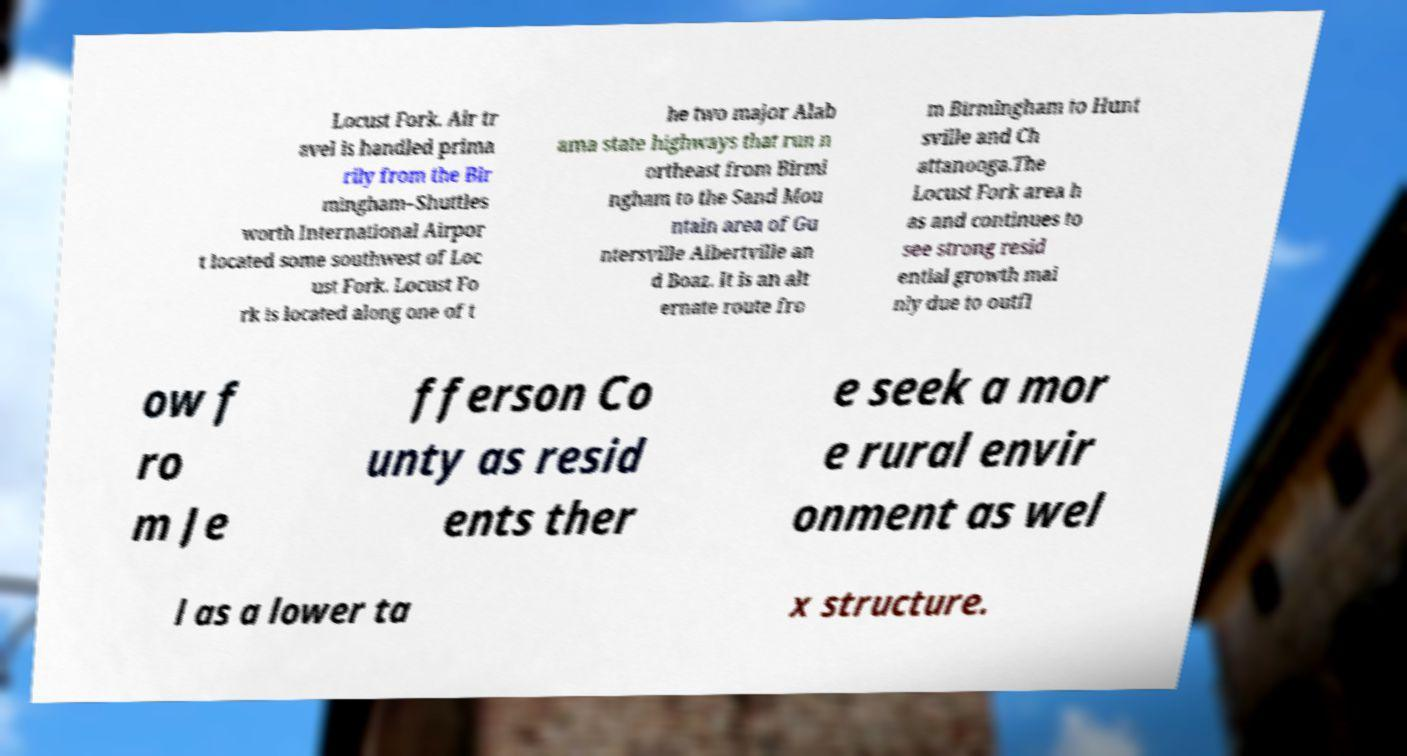Please read and relay the text visible in this image. What does it say? Locust Fork. Air tr avel is handled prima rily from the Bir mingham–Shuttles worth International Airpor t located some southwest of Loc ust Fork. Locust Fo rk is located along one of t he two major Alab ama state highways that run n ortheast from Birmi ngham to the Sand Mou ntain area of Gu ntersville Albertville an d Boaz. It is an alt ernate route fro m Birmingham to Hunt sville and Ch attanooga.The Locust Fork area h as and continues to see strong resid ential growth mai nly due to outfl ow f ro m Je fferson Co unty as resid ents ther e seek a mor e rural envir onment as wel l as a lower ta x structure. 